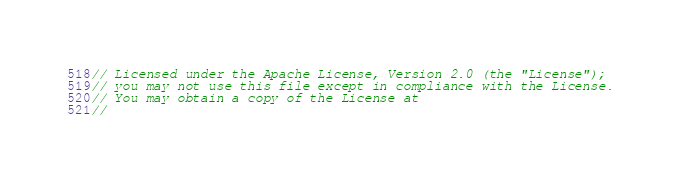<code> <loc_0><loc_0><loc_500><loc_500><_C++_>// Licensed under the Apache License, Version 2.0 (the "License");
// you may not use this file except in compliance with the License.
// You may obtain a copy of the License at
//</code> 